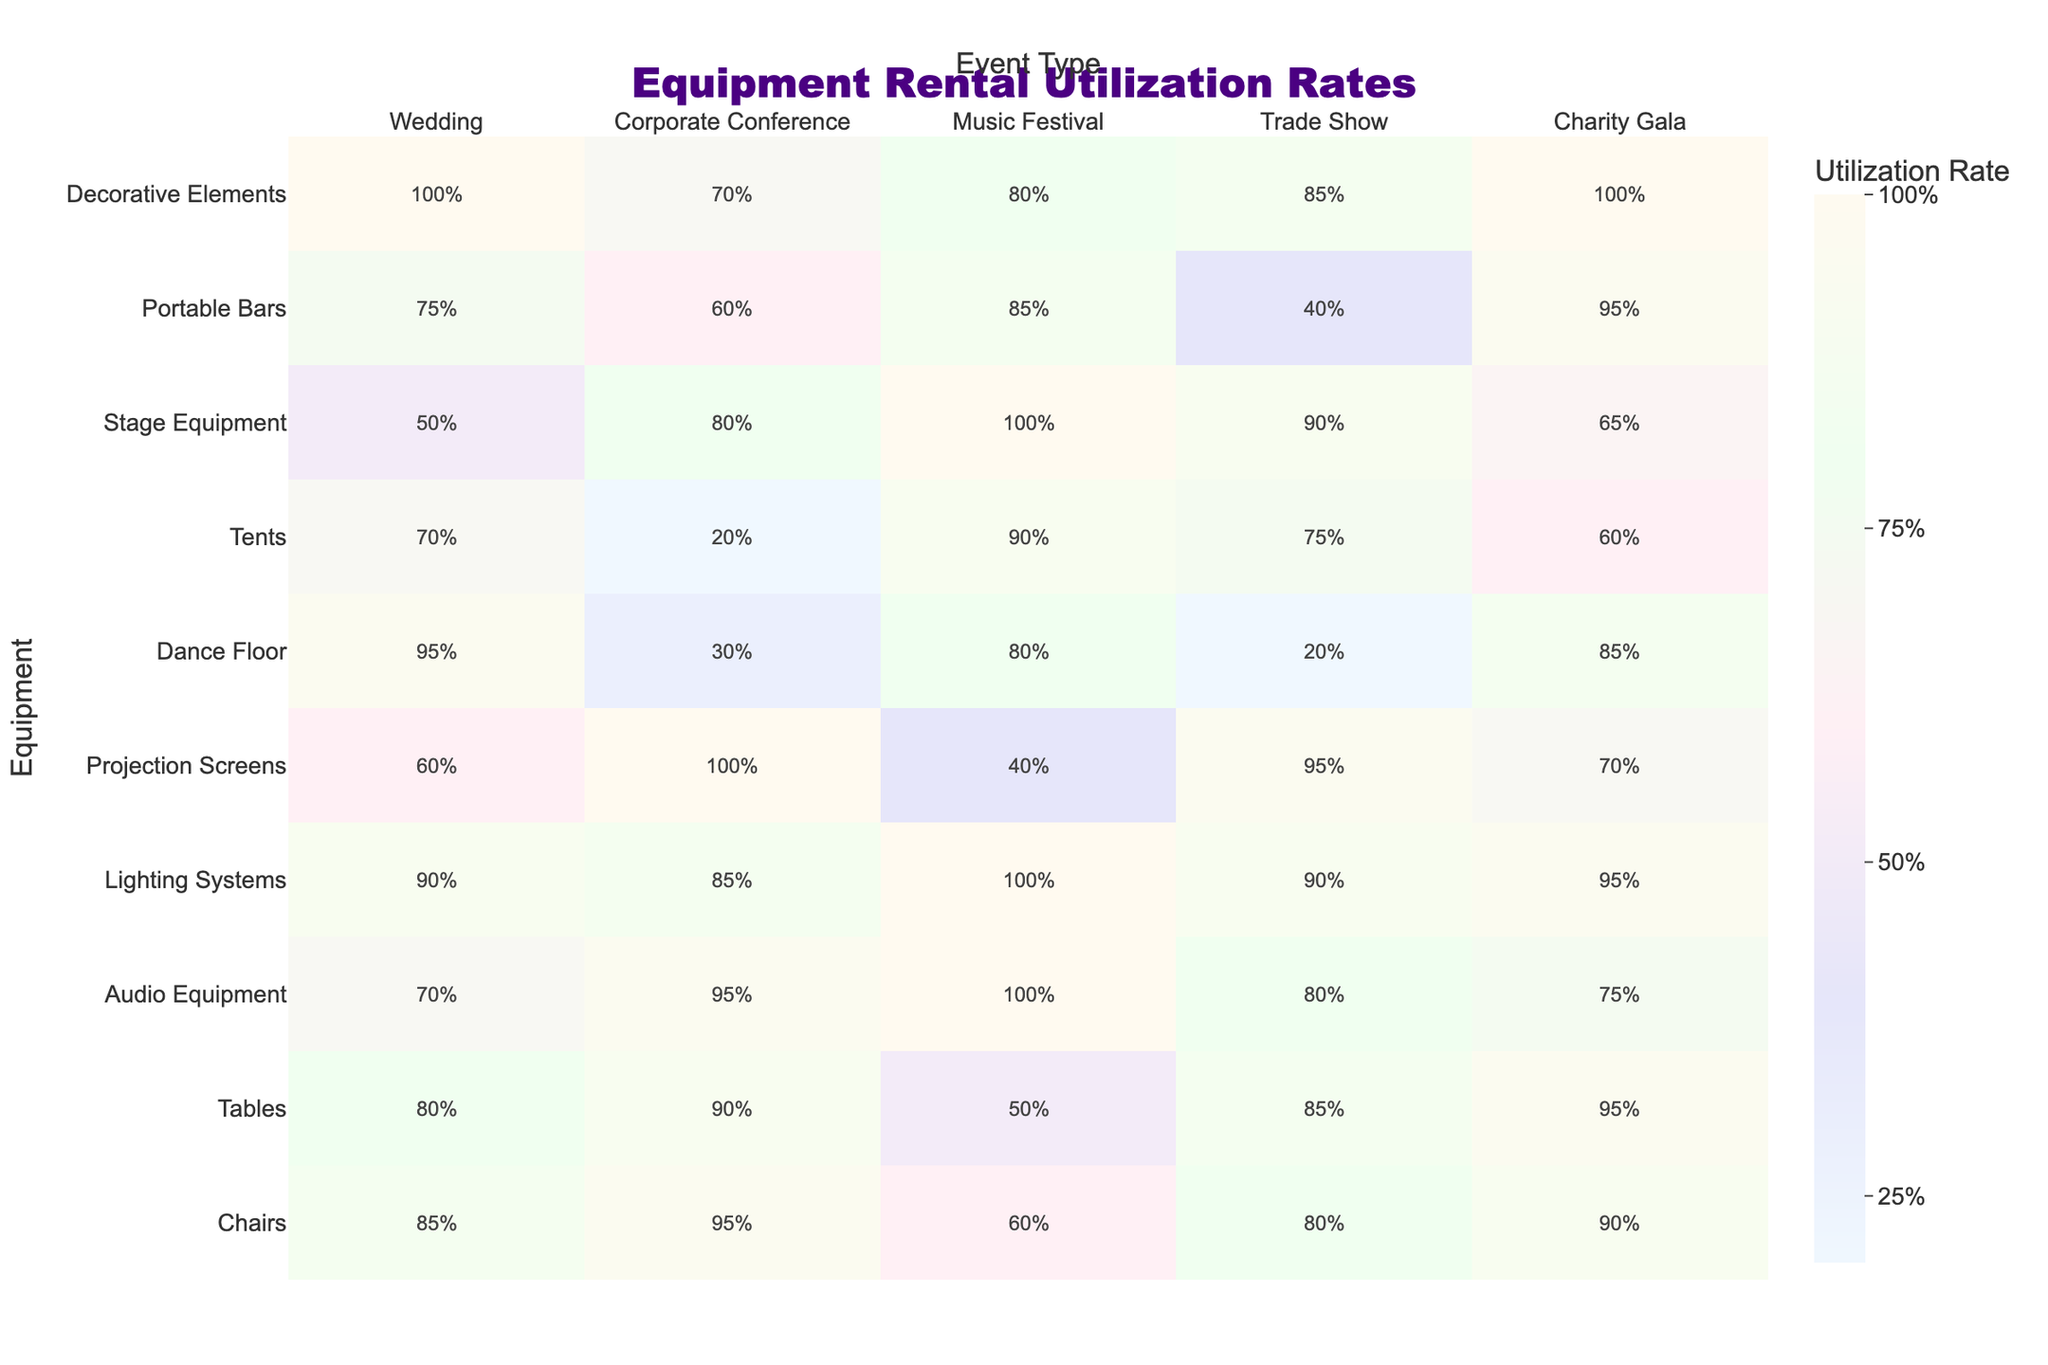What is the utilization rate for chairs at a Corporate Conference? The utilization rate for chairs at a Corporate Conference is listed directly in the table as 95%.
Answer: 95% Which equipment has the highest utilization rate at a Music Festival? The table shows that audio equipment has a utilization rate of 100%, which is the highest among all equipment for Music Festivals.
Answer: Audio Equipment What is the average utilization rate for tables across all event types? To find the average, sum the rates for tables (80% + 90% + 50% + 85% + 95%) = 400%. There are 5 event types, so the average is 400%/5 = 80%.
Answer: 80% Is the utilization rate for tents higher at Trade Shows or Charity Galas? The utilization rate for tents is 75% at Trade Shows and 60% at Charity Galas. Since 75% is greater than 60%, the rate for tents is higher at Trade Shows.
Answer: Yes What equipment has a lower utilization rate at Weddings compared to Charity Galas? Looking at the table, the utilization rates for the equipment are chairs (85% vs. 90%), tables (80% vs. 95%), and portable bars (75% vs. 95%). All these have lower rates at Weddings than at Charity Galas.
Answer: Chairs, Tables, Portable Bars If a corporate event were to use audio equipment and dance floor, what would be the average utilization rate for these two pieces of equipment? The utilization rate for audio equipment is 95% and for the dance floor is 30%. The average of these two is (95% + 30%) / 2 = 62.5%.
Answer: 62.5% Is it true that no event type shows 100% utilization for both lighting systems and audio equipment? The table reveals that the Music Festival shows 100% utilization for audio equipment and also shows 100% for lighting systems. Hence, it's false that no event type shows 100% for both.
Answer: No Which type of event has the lowest overall utilization rates when considering all types of equipment? To find this, we can look at the lowest rates across each type of equipment for each event type. The dance floor at a Music Festival (80%), stage equipment at a Charity Gala (65%), and tents at a Corporate Conference (20%) all contribute to the lower rates. By identifying the lowest values for each equipment type and averaging them, we find that the Corporate Conference has the lowest overall utilization rates.
Answer: Corporate Conference What is the difference in utilization rates between chairs and tables for Trade Shows? By looking at the table, chairs have a utilization rate of 80% and tables have 85% for Trade Shows. The difference is 85% - 80% = 5%.
Answer: 5% Which type of event shows the most consistent utilization rates across the equipment categories? Evaluating the rates for each category, the Charity Gala shows the smallest range in utilization rates (60% for tents and 100% for decorative elements). The rates do not fluctuate as much compared to other events.
Answer: Charity Gala 